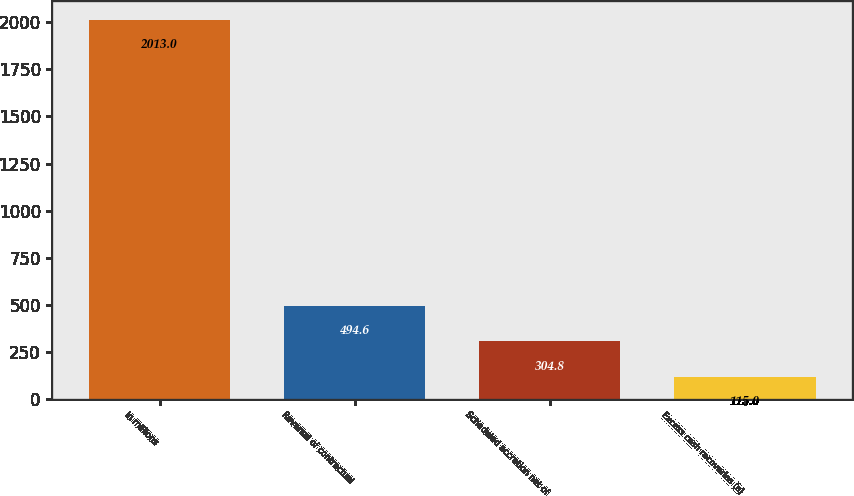Convert chart to OTSL. <chart><loc_0><loc_0><loc_500><loc_500><bar_chart><fcel>In millions<fcel>Reversal of contractual<fcel>Scheduled accretion net of<fcel>Excess cash recoveries (a)<nl><fcel>2013<fcel>494.6<fcel>304.8<fcel>115<nl></chart> 